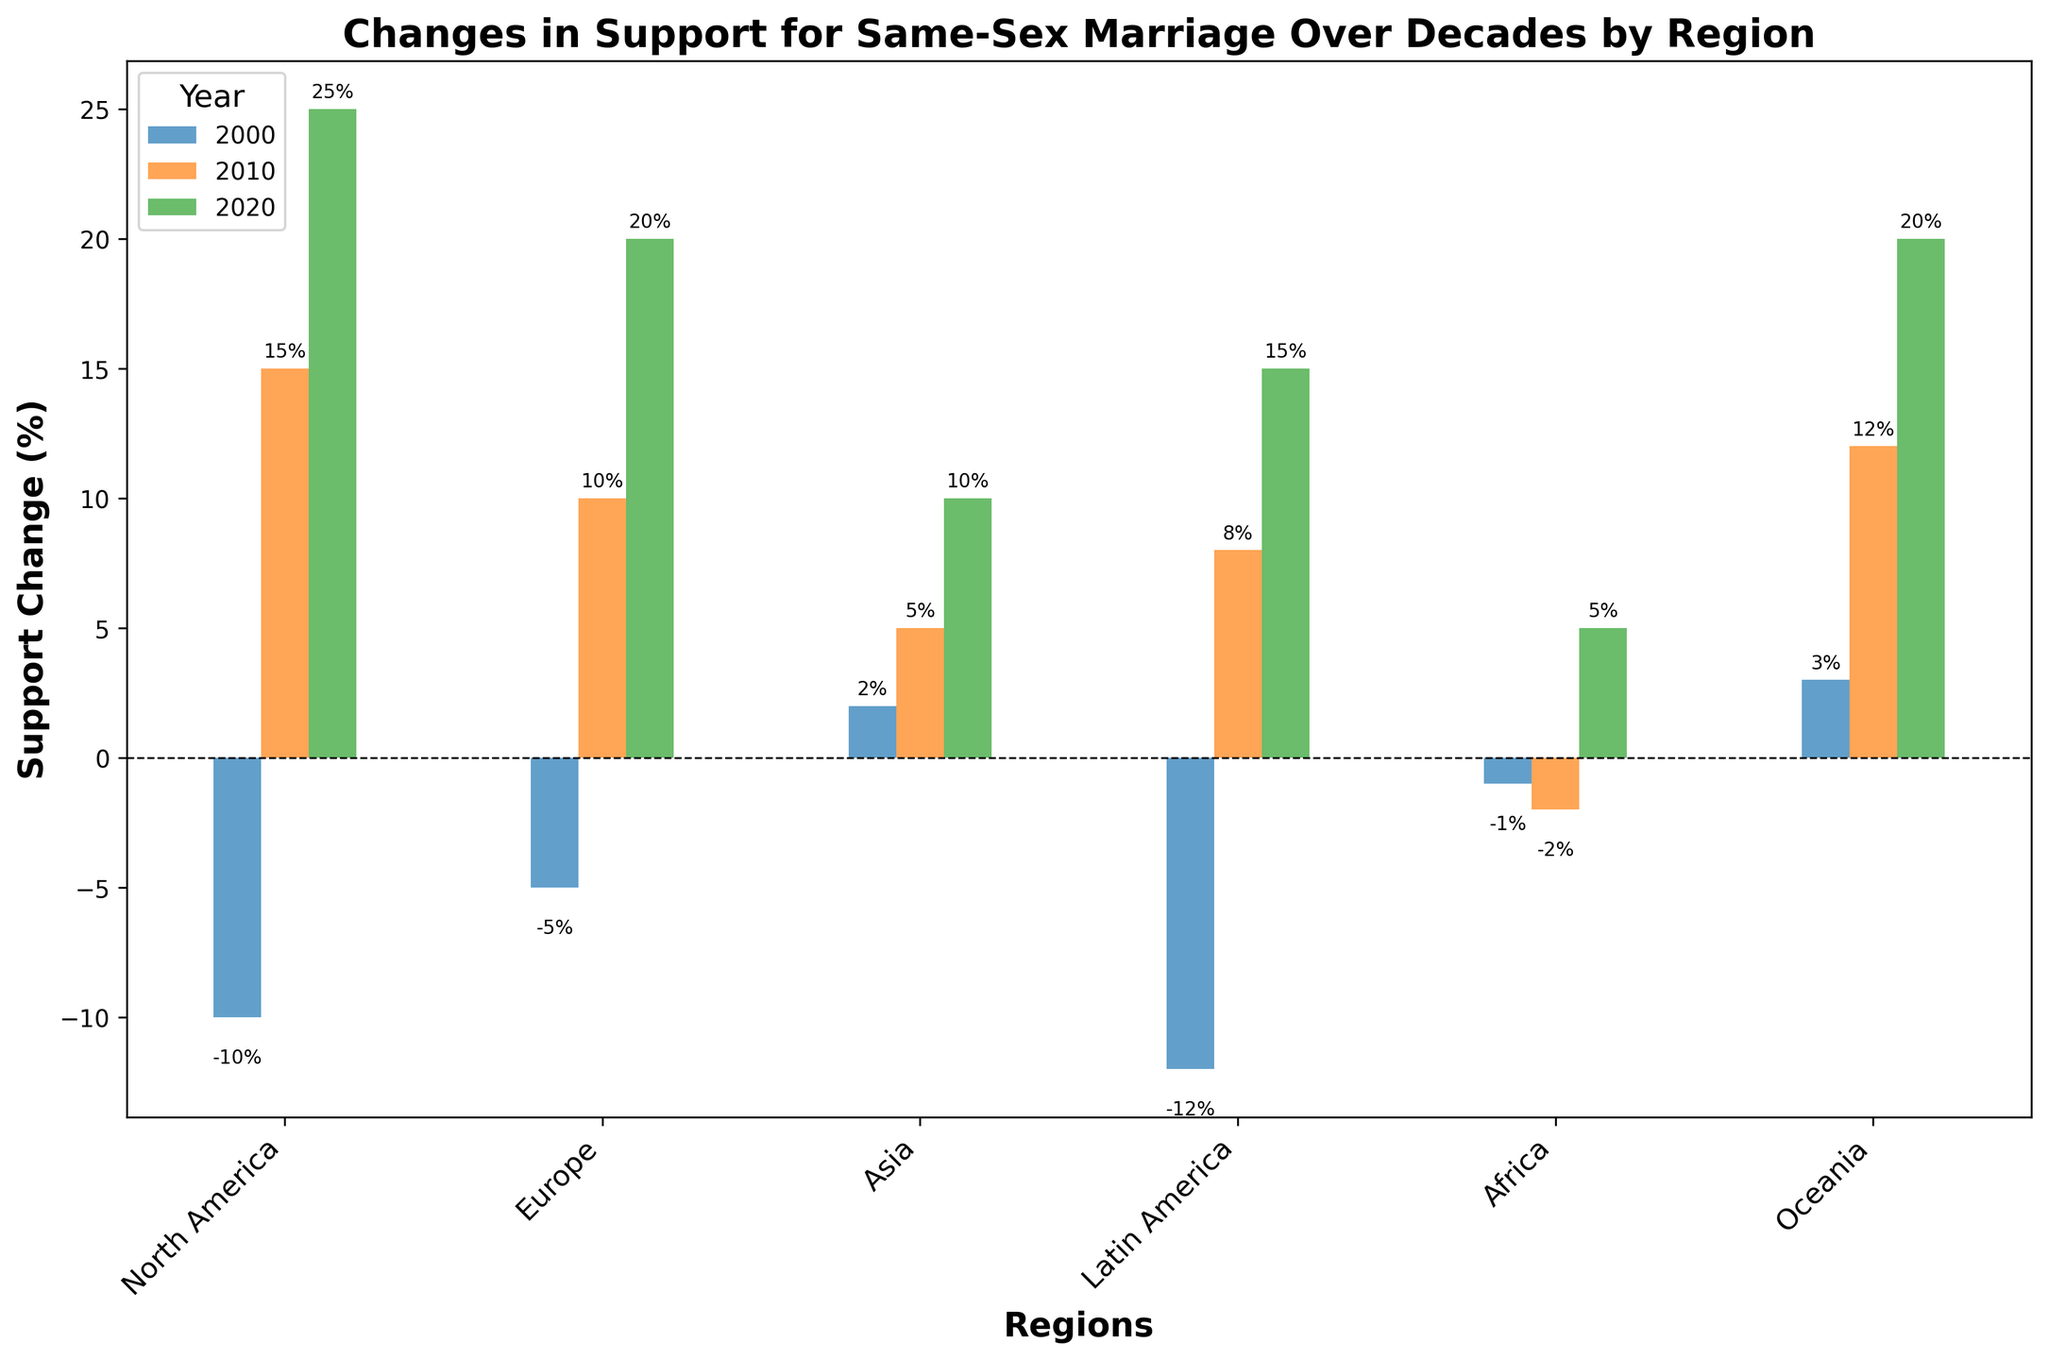Which region experienced the largest positive change in support for same-sex marriage in the 2020s? The highest bar in the 2020 segment (color associated with 2020) indicates the region with the largest positive change. In 2020, North America and Oceania have bars close to or at the top, but North America's bar is the highest.
Answer: North America Which region saw a decline in support for same-sex marriage in 2000? The bars below the 0% line represent a decline in support. In 2000, North America, Europe, and Latin America have bars under the 0% line and show declines.
Answer: North America, Europe, Latin America What is the difference in support change between Europe and Asia in 2020? In 2020, reference the height of the bars for Europe and Asia. Europe's bar is at 20%, and Asia's is at 10%. Subtract Asia's support change from Europe's. 20% - 10% = 10%.
Answer: 10% How many regions show a positive change in support for same-sex marriage in 2010? In 2010, count the number of bars above the 0% line. North America, Europe, Asia, Latin America, and Oceania all show positive changes.
Answer: 5 Which year did Oceania see the highest increase in support for same-sex marriage? Look at the height of the bars for Oceania across all years. Oceania’s highest bar corresponds to the year 2020 at 20%.
Answer: 2020 In which decade did Africa show a positive change in support? Identify African bars that are above the 0% line. In 2020, Africa's bar shows a positive change at 5%. In 2000 and 2010, the changes are negative.
Answer: 2020 What is the average support change for Latin America across all years? Add the support change for each decade (−12% in 2000, 8% in 2010, 15% in 2020), then divide by the number of decades (3). (−12 + 8 + 15) / 3 = 11 / 3 ≈ 3.67.
Answer: 3.67% Did any region consistently show positive support change across all measured decades? Check if any region's bars are all above the 0% line for each year. Oceania's bars for 2000, 2010, and 2020 are consistently positive.
Answer: Oceania Which two regions had the closest support change values in 2010? In 2010, compare the heights of the bars visually to find regions with similar values. Europe (10%) and Latin America (8%) have the closest values.
Answer: Europe and Latin America Which decade saw the largest difference in support change between North America and Africa? Calculate the difference in support change for each year. In 2000: -10 - (-1) = -9, In 2010: 15 - (-2) = 17, In 2020: 25 - 5 = 20. The largest difference is in 2020 (20%).
Answer: 2020 